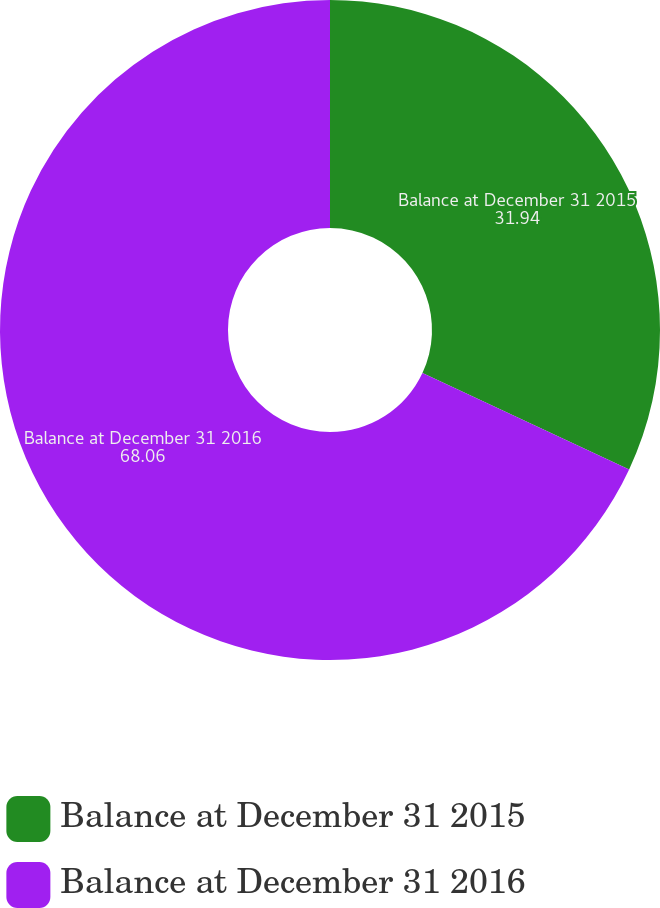Convert chart to OTSL. <chart><loc_0><loc_0><loc_500><loc_500><pie_chart><fcel>Balance at December 31 2015<fcel>Balance at December 31 2016<nl><fcel>31.94%<fcel>68.06%<nl></chart> 